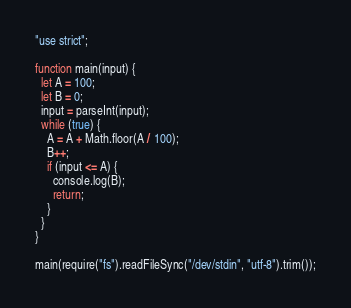Convert code to text. <code><loc_0><loc_0><loc_500><loc_500><_JavaScript_>"use strict";

function main(input) {
  let A = 100;
  let B = 0;
  input = parseInt(input);
  while (true) {
    A = A + Math.floor(A / 100);
    B++;
    if (input <= A) {
      console.log(B);
      return;
    }
  }
}

main(require("fs").readFileSync("/dev/stdin", "utf-8").trim());
</code> 